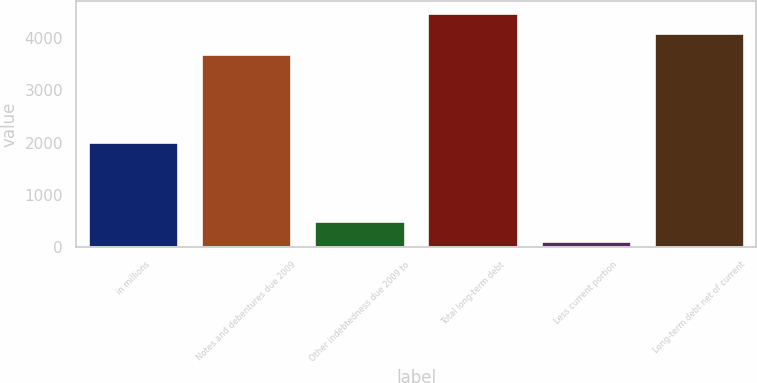Convert chart to OTSL. <chart><loc_0><loc_0><loc_500><loc_500><bar_chart><fcel>in millions<fcel>Notes and debentures due 2009<fcel>Other indebtedness due 2009 to<fcel>Total long-term debt<fcel>Less current portion<fcel>Long-term debt net of current<nl><fcel>2007<fcel>3705<fcel>502.8<fcel>4488.6<fcel>111<fcel>4096.8<nl></chart> 